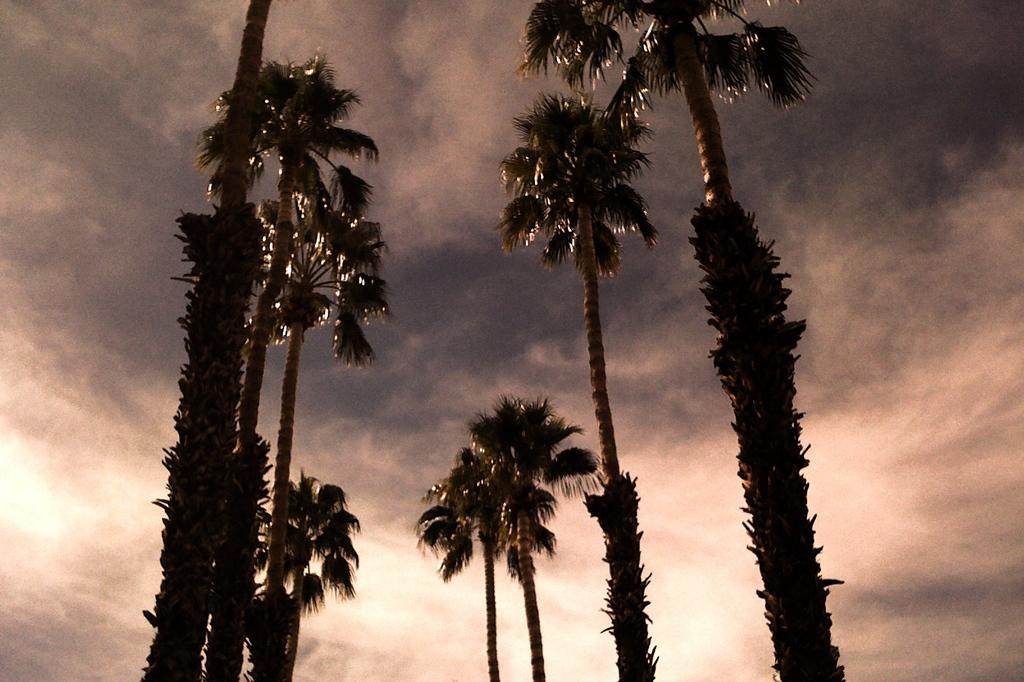What type of vegetation can be seen in the image? There are trees in the image. What is visible behind the trees in the image? The sky is visible behind the trees. What can be observed in the sky in the image? Clouds are present in the sky. What type of sound can be heard coming from the trees in the image? There is no sound present in the image, as it is a still photograph. 